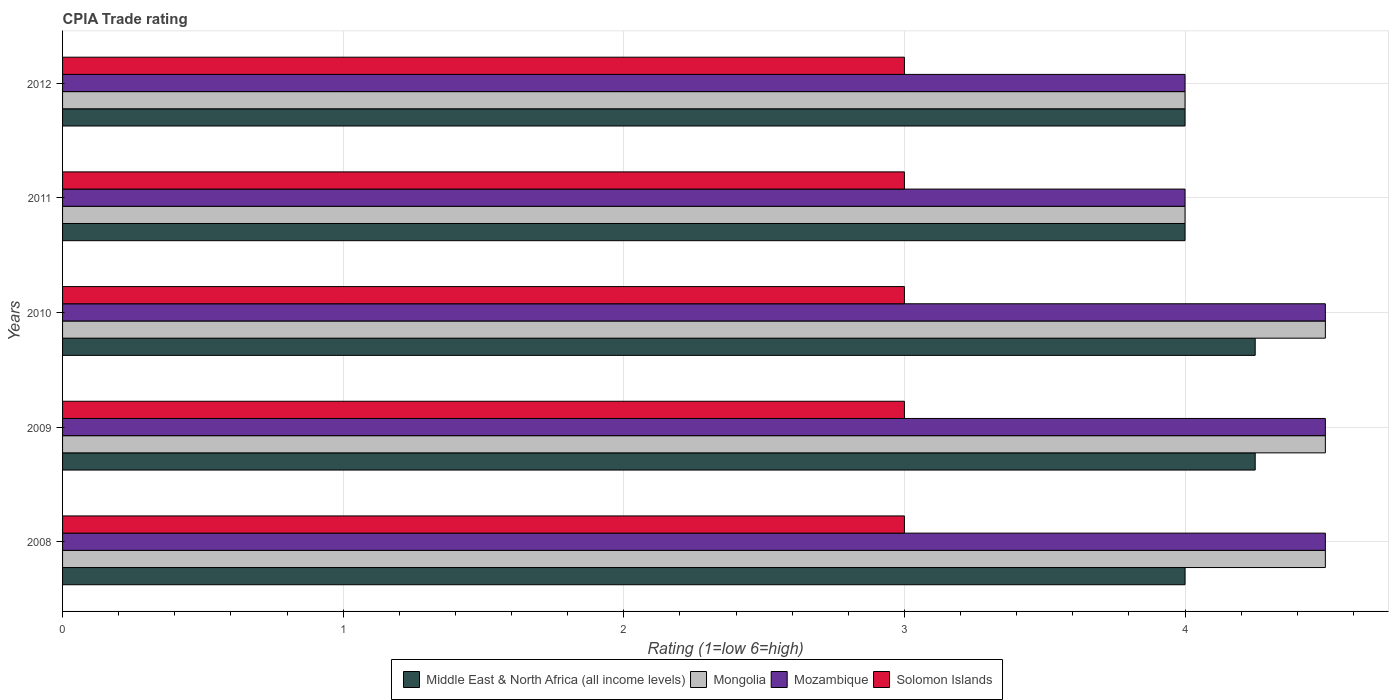How many different coloured bars are there?
Your response must be concise. 4. Are the number of bars per tick equal to the number of legend labels?
Provide a short and direct response. Yes. Are the number of bars on each tick of the Y-axis equal?
Offer a very short reply. Yes. How many bars are there on the 4th tick from the top?
Keep it short and to the point. 4. In how many cases, is the number of bars for a given year not equal to the number of legend labels?
Provide a succinct answer. 0. Across all years, what is the maximum CPIA rating in Middle East & North Africa (all income levels)?
Provide a succinct answer. 4.25. In which year was the CPIA rating in Mongolia maximum?
Ensure brevity in your answer.  2008. What is the total CPIA rating in Middle East & North Africa (all income levels) in the graph?
Keep it short and to the point. 20.5. In the year 2010, what is the difference between the CPIA rating in Solomon Islands and CPIA rating in Middle East & North Africa (all income levels)?
Make the answer very short. -1.25. In how many years, is the CPIA rating in Mongolia greater than 3.6 ?
Your answer should be compact. 5. What is the ratio of the CPIA rating in Mozambique in 2008 to that in 2011?
Keep it short and to the point. 1.12. Is the CPIA rating in Mozambique in 2009 less than that in 2010?
Offer a very short reply. No. What is the difference between the highest and the second highest CPIA rating in Solomon Islands?
Provide a succinct answer. 0. In how many years, is the CPIA rating in Solomon Islands greater than the average CPIA rating in Solomon Islands taken over all years?
Give a very brief answer. 0. Is the sum of the CPIA rating in Mozambique in 2009 and 2010 greater than the maximum CPIA rating in Middle East & North Africa (all income levels) across all years?
Make the answer very short. Yes. Is it the case that in every year, the sum of the CPIA rating in Middle East & North Africa (all income levels) and CPIA rating in Solomon Islands is greater than the sum of CPIA rating in Mozambique and CPIA rating in Mongolia?
Give a very brief answer. No. What does the 4th bar from the top in 2012 represents?
Keep it short and to the point. Middle East & North Africa (all income levels). What does the 1st bar from the bottom in 2009 represents?
Your answer should be very brief. Middle East & North Africa (all income levels). How many years are there in the graph?
Provide a succinct answer. 5. Does the graph contain any zero values?
Give a very brief answer. No. Does the graph contain grids?
Your answer should be very brief. Yes. Where does the legend appear in the graph?
Offer a terse response. Bottom center. What is the title of the graph?
Offer a very short reply. CPIA Trade rating. What is the label or title of the Y-axis?
Offer a very short reply. Years. What is the Rating (1=low 6=high) in Middle East & North Africa (all income levels) in 2008?
Your answer should be compact. 4. What is the Rating (1=low 6=high) in Mongolia in 2008?
Provide a succinct answer. 4.5. What is the Rating (1=low 6=high) in Mozambique in 2008?
Give a very brief answer. 4.5. What is the Rating (1=low 6=high) in Solomon Islands in 2008?
Keep it short and to the point. 3. What is the Rating (1=low 6=high) of Middle East & North Africa (all income levels) in 2009?
Offer a very short reply. 4.25. What is the Rating (1=low 6=high) of Mongolia in 2009?
Offer a terse response. 4.5. What is the Rating (1=low 6=high) in Solomon Islands in 2009?
Make the answer very short. 3. What is the Rating (1=low 6=high) of Middle East & North Africa (all income levels) in 2010?
Ensure brevity in your answer.  4.25. What is the Rating (1=low 6=high) in Mongolia in 2010?
Make the answer very short. 4.5. What is the Rating (1=low 6=high) in Mozambique in 2010?
Your answer should be very brief. 4.5. What is the Rating (1=low 6=high) of Mongolia in 2011?
Ensure brevity in your answer.  4. What is the Rating (1=low 6=high) of Middle East & North Africa (all income levels) in 2012?
Provide a succinct answer. 4. What is the Rating (1=low 6=high) of Mongolia in 2012?
Give a very brief answer. 4. What is the Rating (1=low 6=high) in Mozambique in 2012?
Provide a short and direct response. 4. Across all years, what is the maximum Rating (1=low 6=high) in Middle East & North Africa (all income levels)?
Give a very brief answer. 4.25. Across all years, what is the minimum Rating (1=low 6=high) in Middle East & North Africa (all income levels)?
Provide a succinct answer. 4. Across all years, what is the minimum Rating (1=low 6=high) in Mozambique?
Ensure brevity in your answer.  4. What is the total Rating (1=low 6=high) of Mongolia in the graph?
Make the answer very short. 21.5. What is the difference between the Rating (1=low 6=high) of Solomon Islands in 2008 and that in 2009?
Provide a succinct answer. 0. What is the difference between the Rating (1=low 6=high) of Mongolia in 2008 and that in 2010?
Ensure brevity in your answer.  0. What is the difference between the Rating (1=low 6=high) in Mozambique in 2008 and that in 2010?
Offer a terse response. 0. What is the difference between the Rating (1=low 6=high) of Middle East & North Africa (all income levels) in 2008 and that in 2011?
Provide a succinct answer. 0. What is the difference between the Rating (1=low 6=high) of Solomon Islands in 2008 and that in 2011?
Offer a terse response. 0. What is the difference between the Rating (1=low 6=high) in Middle East & North Africa (all income levels) in 2008 and that in 2012?
Ensure brevity in your answer.  0. What is the difference between the Rating (1=low 6=high) in Mozambique in 2008 and that in 2012?
Offer a very short reply. 0.5. What is the difference between the Rating (1=low 6=high) in Solomon Islands in 2008 and that in 2012?
Provide a short and direct response. 0. What is the difference between the Rating (1=low 6=high) of Mongolia in 2009 and that in 2010?
Provide a succinct answer. 0. What is the difference between the Rating (1=low 6=high) of Solomon Islands in 2009 and that in 2010?
Make the answer very short. 0. What is the difference between the Rating (1=low 6=high) in Mongolia in 2009 and that in 2011?
Your answer should be compact. 0.5. What is the difference between the Rating (1=low 6=high) in Mozambique in 2009 and that in 2011?
Your answer should be compact. 0.5. What is the difference between the Rating (1=low 6=high) of Solomon Islands in 2009 and that in 2011?
Your answer should be compact. 0. What is the difference between the Rating (1=low 6=high) of Middle East & North Africa (all income levels) in 2009 and that in 2012?
Offer a very short reply. 0.25. What is the difference between the Rating (1=low 6=high) in Mongolia in 2009 and that in 2012?
Offer a very short reply. 0.5. What is the difference between the Rating (1=low 6=high) of Mozambique in 2009 and that in 2012?
Offer a terse response. 0.5. What is the difference between the Rating (1=low 6=high) of Middle East & North Africa (all income levels) in 2010 and that in 2011?
Provide a succinct answer. 0.25. What is the difference between the Rating (1=low 6=high) of Mongolia in 2010 and that in 2011?
Make the answer very short. 0.5. What is the difference between the Rating (1=low 6=high) in Mozambique in 2010 and that in 2011?
Make the answer very short. 0.5. What is the difference between the Rating (1=low 6=high) of Mongolia in 2010 and that in 2012?
Give a very brief answer. 0.5. What is the difference between the Rating (1=low 6=high) of Mozambique in 2010 and that in 2012?
Make the answer very short. 0.5. What is the difference between the Rating (1=low 6=high) in Solomon Islands in 2010 and that in 2012?
Your response must be concise. 0. What is the difference between the Rating (1=low 6=high) in Middle East & North Africa (all income levels) in 2011 and that in 2012?
Your response must be concise. 0. What is the difference between the Rating (1=low 6=high) in Middle East & North Africa (all income levels) in 2008 and the Rating (1=low 6=high) in Solomon Islands in 2009?
Give a very brief answer. 1. What is the difference between the Rating (1=low 6=high) of Mongolia in 2008 and the Rating (1=low 6=high) of Solomon Islands in 2009?
Ensure brevity in your answer.  1.5. What is the difference between the Rating (1=low 6=high) in Middle East & North Africa (all income levels) in 2008 and the Rating (1=low 6=high) in Mongolia in 2010?
Offer a very short reply. -0.5. What is the difference between the Rating (1=low 6=high) of Middle East & North Africa (all income levels) in 2008 and the Rating (1=low 6=high) of Mozambique in 2010?
Keep it short and to the point. -0.5. What is the difference between the Rating (1=low 6=high) in Middle East & North Africa (all income levels) in 2008 and the Rating (1=low 6=high) in Solomon Islands in 2010?
Ensure brevity in your answer.  1. What is the difference between the Rating (1=low 6=high) in Mongolia in 2008 and the Rating (1=low 6=high) in Solomon Islands in 2010?
Give a very brief answer. 1.5. What is the difference between the Rating (1=low 6=high) of Middle East & North Africa (all income levels) in 2008 and the Rating (1=low 6=high) of Mongolia in 2011?
Provide a succinct answer. 0. What is the difference between the Rating (1=low 6=high) in Middle East & North Africa (all income levels) in 2008 and the Rating (1=low 6=high) in Solomon Islands in 2011?
Your response must be concise. 1. What is the difference between the Rating (1=low 6=high) of Mongolia in 2008 and the Rating (1=low 6=high) of Mozambique in 2011?
Your response must be concise. 0.5. What is the difference between the Rating (1=low 6=high) in Mozambique in 2008 and the Rating (1=low 6=high) in Solomon Islands in 2011?
Your answer should be compact. 1.5. What is the difference between the Rating (1=low 6=high) of Mongolia in 2008 and the Rating (1=low 6=high) of Mozambique in 2012?
Make the answer very short. 0.5. What is the difference between the Rating (1=low 6=high) in Middle East & North Africa (all income levels) in 2009 and the Rating (1=low 6=high) in Mongolia in 2010?
Your answer should be very brief. -0.25. What is the difference between the Rating (1=low 6=high) of Middle East & North Africa (all income levels) in 2009 and the Rating (1=low 6=high) of Mozambique in 2010?
Ensure brevity in your answer.  -0.25. What is the difference between the Rating (1=low 6=high) of Middle East & North Africa (all income levels) in 2009 and the Rating (1=low 6=high) of Solomon Islands in 2010?
Provide a short and direct response. 1.25. What is the difference between the Rating (1=low 6=high) of Mongolia in 2009 and the Rating (1=low 6=high) of Solomon Islands in 2010?
Provide a short and direct response. 1.5. What is the difference between the Rating (1=low 6=high) of Mozambique in 2009 and the Rating (1=low 6=high) of Solomon Islands in 2010?
Your response must be concise. 1.5. What is the difference between the Rating (1=low 6=high) of Middle East & North Africa (all income levels) in 2009 and the Rating (1=low 6=high) of Mongolia in 2011?
Provide a succinct answer. 0.25. What is the difference between the Rating (1=low 6=high) of Mongolia in 2009 and the Rating (1=low 6=high) of Solomon Islands in 2011?
Offer a very short reply. 1.5. What is the difference between the Rating (1=low 6=high) of Mozambique in 2009 and the Rating (1=low 6=high) of Solomon Islands in 2011?
Your answer should be very brief. 1.5. What is the difference between the Rating (1=low 6=high) in Middle East & North Africa (all income levels) in 2009 and the Rating (1=low 6=high) in Mongolia in 2012?
Keep it short and to the point. 0.25. What is the difference between the Rating (1=low 6=high) in Middle East & North Africa (all income levels) in 2009 and the Rating (1=low 6=high) in Solomon Islands in 2012?
Provide a short and direct response. 1.25. What is the difference between the Rating (1=low 6=high) of Mozambique in 2009 and the Rating (1=low 6=high) of Solomon Islands in 2012?
Your answer should be very brief. 1.5. What is the difference between the Rating (1=low 6=high) of Middle East & North Africa (all income levels) in 2010 and the Rating (1=low 6=high) of Mongolia in 2011?
Offer a very short reply. 0.25. What is the difference between the Rating (1=low 6=high) in Middle East & North Africa (all income levels) in 2010 and the Rating (1=low 6=high) in Mozambique in 2011?
Keep it short and to the point. 0.25. What is the difference between the Rating (1=low 6=high) in Middle East & North Africa (all income levels) in 2010 and the Rating (1=low 6=high) in Solomon Islands in 2012?
Provide a succinct answer. 1.25. What is the difference between the Rating (1=low 6=high) of Mozambique in 2010 and the Rating (1=low 6=high) of Solomon Islands in 2012?
Your answer should be very brief. 1.5. What is the difference between the Rating (1=low 6=high) in Middle East & North Africa (all income levels) in 2011 and the Rating (1=low 6=high) in Mongolia in 2012?
Your answer should be compact. 0. What is the difference between the Rating (1=low 6=high) of Mongolia in 2011 and the Rating (1=low 6=high) of Mozambique in 2012?
Provide a short and direct response. 0. What is the difference between the Rating (1=low 6=high) of Mongolia in 2011 and the Rating (1=low 6=high) of Solomon Islands in 2012?
Keep it short and to the point. 1. What is the difference between the Rating (1=low 6=high) of Mozambique in 2011 and the Rating (1=low 6=high) of Solomon Islands in 2012?
Keep it short and to the point. 1. What is the average Rating (1=low 6=high) of Mongolia per year?
Offer a terse response. 4.3. What is the average Rating (1=low 6=high) of Mozambique per year?
Your answer should be compact. 4.3. In the year 2008, what is the difference between the Rating (1=low 6=high) in Middle East & North Africa (all income levels) and Rating (1=low 6=high) in Mozambique?
Your answer should be compact. -0.5. In the year 2008, what is the difference between the Rating (1=low 6=high) in Mozambique and Rating (1=low 6=high) in Solomon Islands?
Your response must be concise. 1.5. In the year 2009, what is the difference between the Rating (1=low 6=high) in Middle East & North Africa (all income levels) and Rating (1=low 6=high) in Solomon Islands?
Keep it short and to the point. 1.25. In the year 2009, what is the difference between the Rating (1=low 6=high) in Mongolia and Rating (1=low 6=high) in Mozambique?
Give a very brief answer. 0. In the year 2010, what is the difference between the Rating (1=low 6=high) in Middle East & North Africa (all income levels) and Rating (1=low 6=high) in Mongolia?
Your response must be concise. -0.25. In the year 2010, what is the difference between the Rating (1=low 6=high) of Middle East & North Africa (all income levels) and Rating (1=low 6=high) of Mozambique?
Your answer should be very brief. -0.25. In the year 2010, what is the difference between the Rating (1=low 6=high) in Mozambique and Rating (1=low 6=high) in Solomon Islands?
Your answer should be compact. 1.5. In the year 2012, what is the difference between the Rating (1=low 6=high) in Middle East & North Africa (all income levels) and Rating (1=low 6=high) in Mongolia?
Your answer should be compact. 0. In the year 2012, what is the difference between the Rating (1=low 6=high) in Middle East & North Africa (all income levels) and Rating (1=low 6=high) in Mozambique?
Ensure brevity in your answer.  0. In the year 2012, what is the difference between the Rating (1=low 6=high) in Mongolia and Rating (1=low 6=high) in Solomon Islands?
Keep it short and to the point. 1. What is the ratio of the Rating (1=low 6=high) in Solomon Islands in 2008 to that in 2009?
Provide a short and direct response. 1. What is the ratio of the Rating (1=low 6=high) of Middle East & North Africa (all income levels) in 2008 to that in 2010?
Keep it short and to the point. 0.94. What is the ratio of the Rating (1=low 6=high) of Mongolia in 2008 to that in 2010?
Provide a succinct answer. 1. What is the ratio of the Rating (1=low 6=high) of Mozambique in 2008 to that in 2010?
Provide a succinct answer. 1. What is the ratio of the Rating (1=low 6=high) of Solomon Islands in 2008 to that in 2010?
Ensure brevity in your answer.  1. What is the ratio of the Rating (1=low 6=high) of Middle East & North Africa (all income levels) in 2008 to that in 2011?
Give a very brief answer. 1. What is the ratio of the Rating (1=low 6=high) in Mongolia in 2008 to that in 2011?
Your answer should be very brief. 1.12. What is the ratio of the Rating (1=low 6=high) of Solomon Islands in 2008 to that in 2012?
Your answer should be compact. 1. What is the ratio of the Rating (1=low 6=high) in Middle East & North Africa (all income levels) in 2009 to that in 2010?
Provide a succinct answer. 1. What is the ratio of the Rating (1=low 6=high) of Solomon Islands in 2009 to that in 2010?
Your answer should be compact. 1. What is the ratio of the Rating (1=low 6=high) of Middle East & North Africa (all income levels) in 2009 to that in 2011?
Provide a short and direct response. 1.06. What is the ratio of the Rating (1=low 6=high) in Mongolia in 2009 to that in 2011?
Offer a very short reply. 1.12. What is the ratio of the Rating (1=low 6=high) of Mozambique in 2009 to that in 2011?
Give a very brief answer. 1.12. What is the ratio of the Rating (1=low 6=high) of Solomon Islands in 2009 to that in 2011?
Provide a succinct answer. 1. What is the ratio of the Rating (1=low 6=high) in Solomon Islands in 2009 to that in 2012?
Your response must be concise. 1. What is the ratio of the Rating (1=low 6=high) in Solomon Islands in 2010 to that in 2011?
Provide a succinct answer. 1. What is the ratio of the Rating (1=low 6=high) in Middle East & North Africa (all income levels) in 2010 to that in 2012?
Give a very brief answer. 1.06. What is the ratio of the Rating (1=low 6=high) of Mozambique in 2010 to that in 2012?
Your answer should be very brief. 1.12. What is the ratio of the Rating (1=low 6=high) in Solomon Islands in 2010 to that in 2012?
Keep it short and to the point. 1. What is the ratio of the Rating (1=low 6=high) of Middle East & North Africa (all income levels) in 2011 to that in 2012?
Keep it short and to the point. 1. What is the ratio of the Rating (1=low 6=high) of Mongolia in 2011 to that in 2012?
Provide a succinct answer. 1. What is the ratio of the Rating (1=low 6=high) in Mozambique in 2011 to that in 2012?
Your response must be concise. 1. What is the ratio of the Rating (1=low 6=high) in Solomon Islands in 2011 to that in 2012?
Offer a very short reply. 1. What is the difference between the highest and the second highest Rating (1=low 6=high) in Middle East & North Africa (all income levels)?
Your response must be concise. 0. What is the difference between the highest and the second highest Rating (1=low 6=high) in Mongolia?
Give a very brief answer. 0. What is the difference between the highest and the second highest Rating (1=low 6=high) in Mozambique?
Provide a short and direct response. 0. What is the difference between the highest and the second highest Rating (1=low 6=high) in Solomon Islands?
Your answer should be compact. 0. What is the difference between the highest and the lowest Rating (1=low 6=high) in Mozambique?
Offer a terse response. 0.5. What is the difference between the highest and the lowest Rating (1=low 6=high) of Solomon Islands?
Make the answer very short. 0. 